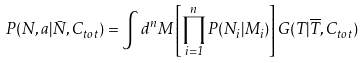<formula> <loc_0><loc_0><loc_500><loc_500>P ( N , a | \bar { N } , C _ { t o t } ) = \int d ^ { n } M \left [ \prod _ { i = 1 } ^ { n } P ( N _ { i } | M _ { i } ) \right ] G ( T | \overline { T } , C _ { t o t } )</formula> 